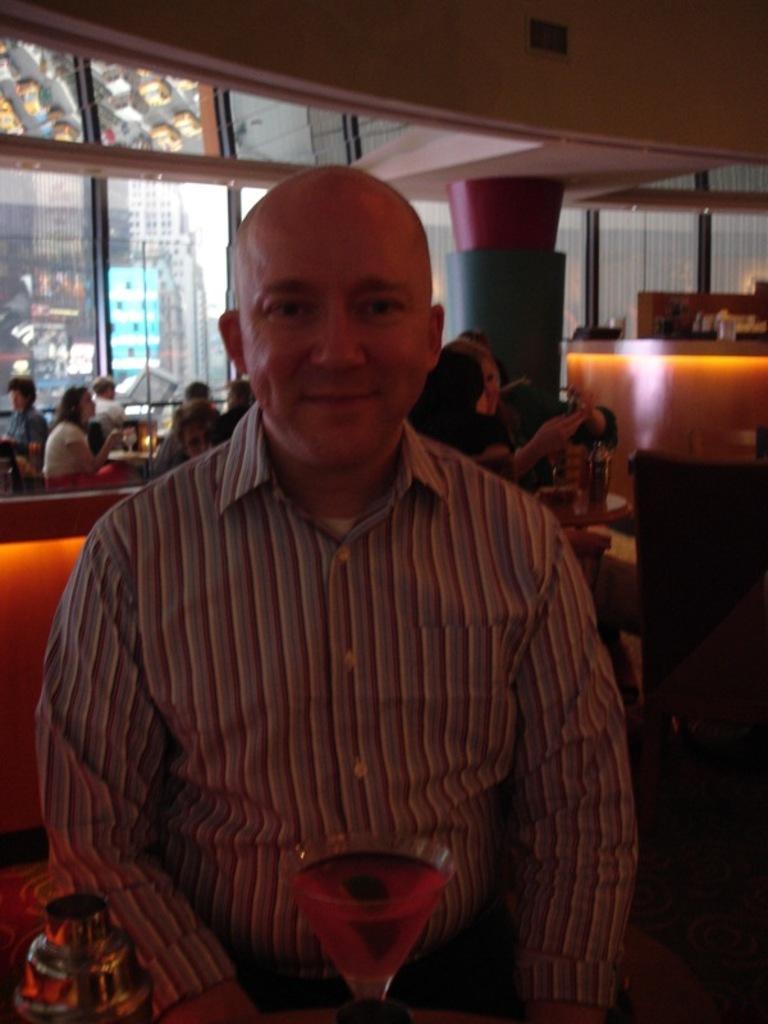Can you describe this image briefly? In this image, I can see man, who is sitting and smiling and in front there is a glass. In the background I can see few people sitting on the couch 